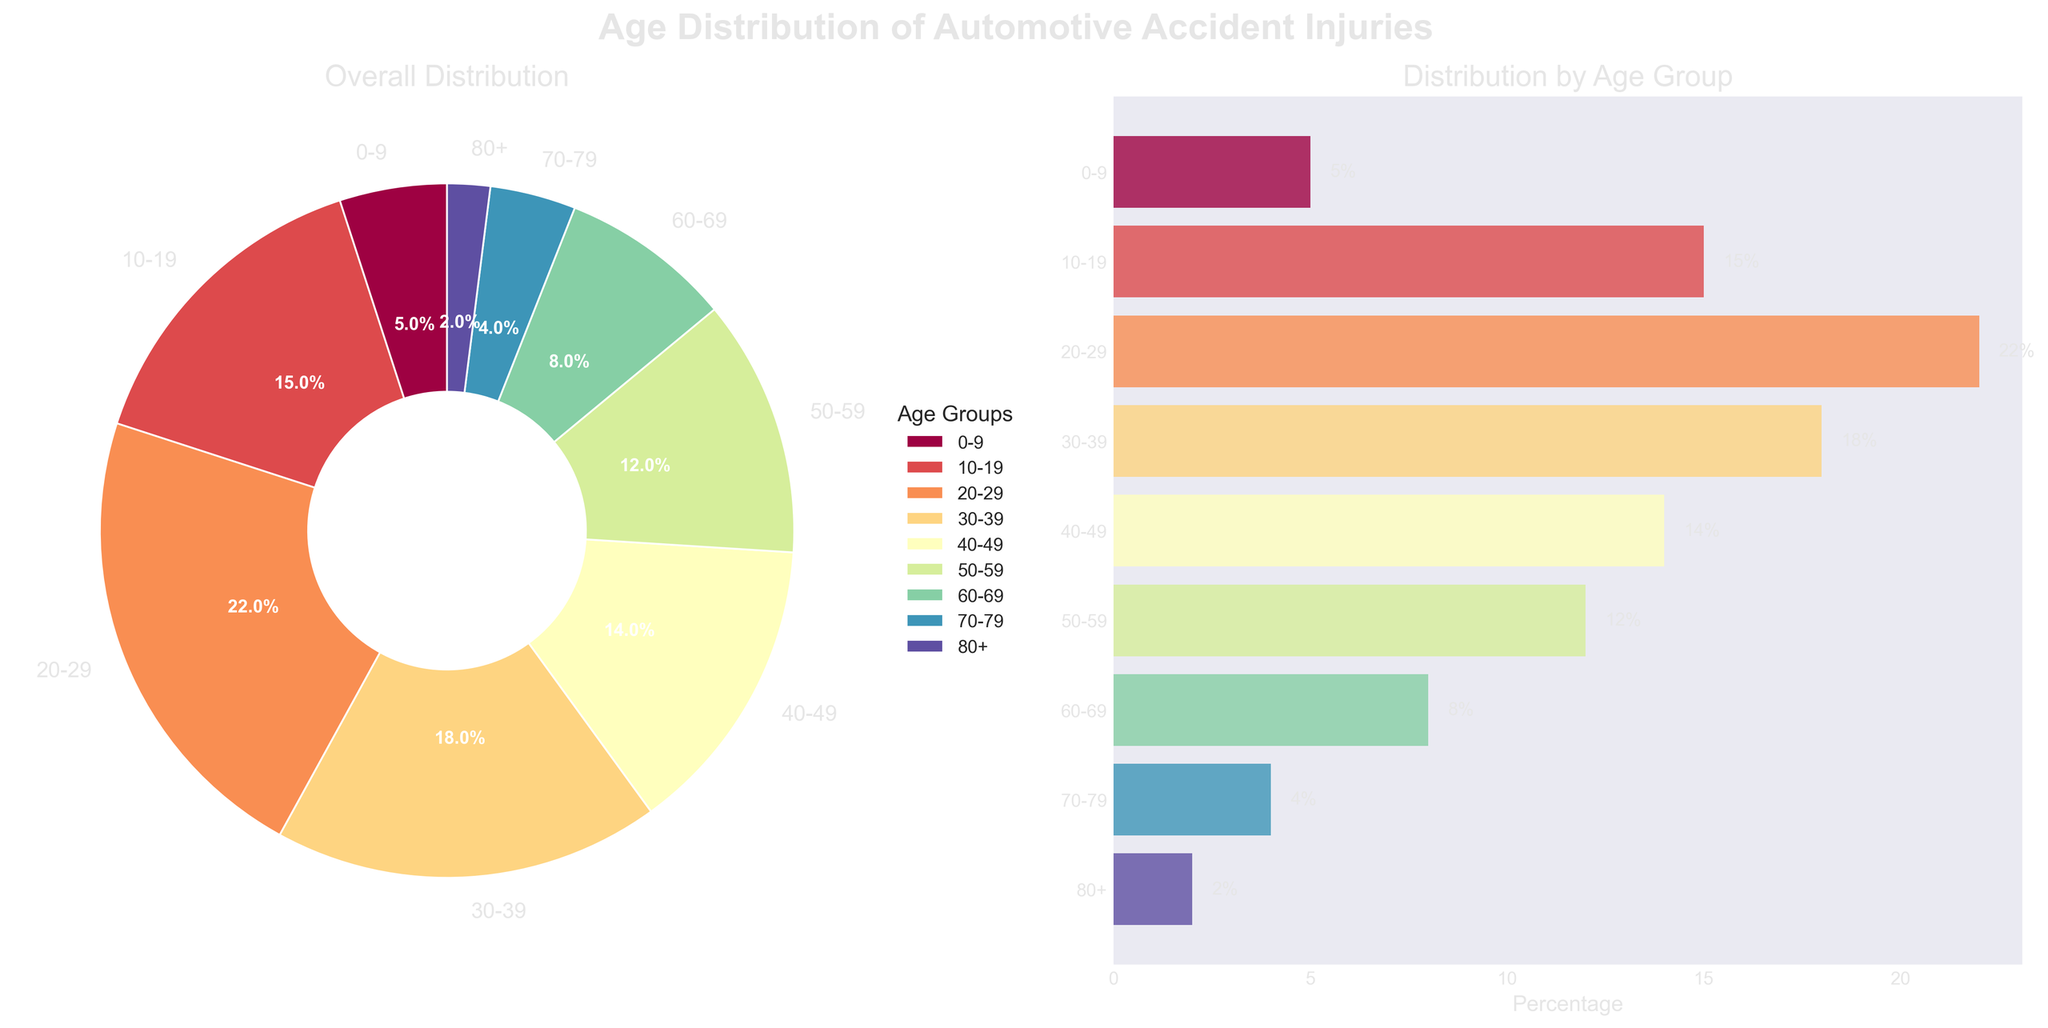Which age group has the highest percentage of automotive accident injuries? The pie chart and horizontal bar chart both show that the 20-29 age group has the highest percentage at 22%
Answer: 20-29 Which two age groups together have more than 50% of the injuries? The age groups 20-29 (22%) and 30-39 (18%) combined have 40%. Adding the 10-19 group (15%) brings the total to 55%
Answer: 20-29 and 10-19 Which age group has the least number of injuries? Both the pie chart and bar chart indicate that the 80+ age group has the lowest percentage at 2%
Answer: 80+ How does the percentage of injuries in the 40-49 age group compare to that in the 50-59 age group? The 40-49 age group is at 14%, which is 2% higher than the 50-59 age group at 12%
Answer: 40-49 is higher by 2% Which age groups have a single-digit percentage of injuries? The bar chart shows that the 0-9 group (5%), 60-69 group (8%), 70-79 group (4%), and 80+ group (2%) all have single-digit percentages
Answer: 0-9, 60-69, 70-79, and 80+ What is the combined percentage of injuries for age groups 0-9, 10-19, and 70-79? Adding the percentages for 0-9 (5%), 10-19 (15%), and 70-79 (4%) gives a total of 24%
Answer: 24% Which age groups have percentages that fall between 10% and 20% inclusive? The bar chart indicates that age groups 10-19 (15%), 30-39 (18%), 40-49 (14%), and 50-59 (12%) fall in this range
Answer: 10-19, 30-39, 40-49, and 50-59 What is the difference in percentage between the 20-29 and 60-69 age groups? The 20-29 group has a percentage of 22% while the 60-69 group has 8%, resulting in a difference of 14%
Answer: 14% How do the percentages of injuries under 30 years of age compare to those 30 years and older? Sum the percentages for 0-9 (5%), 10-19 (15%), and 20-29 (22%) for a total of 42%. Sum the remaining groups (58%)
Answer: Under 30: 42%, 30 and older: 58% What is the title of the charts? Both charts are under the title "Age Distribution of Automotive Accident Injuries"
Answer: Age Distribution of Automotive Accident Injuries 